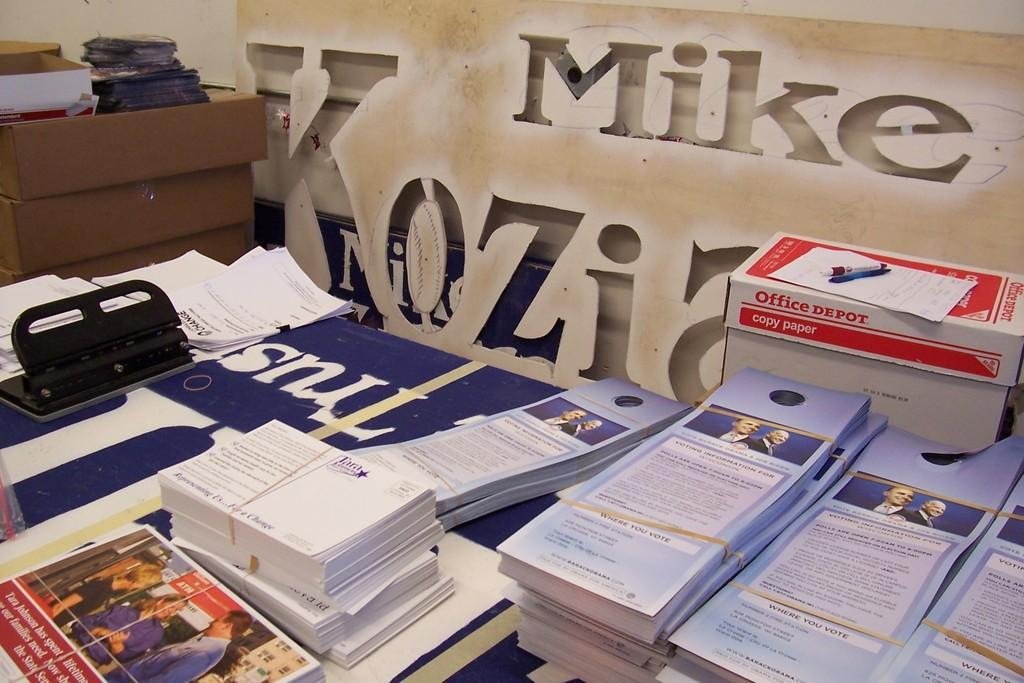Provide a one-sentence caption for the provided image. Pamphlets sitting inf front of sign that says the name Mike on it. 